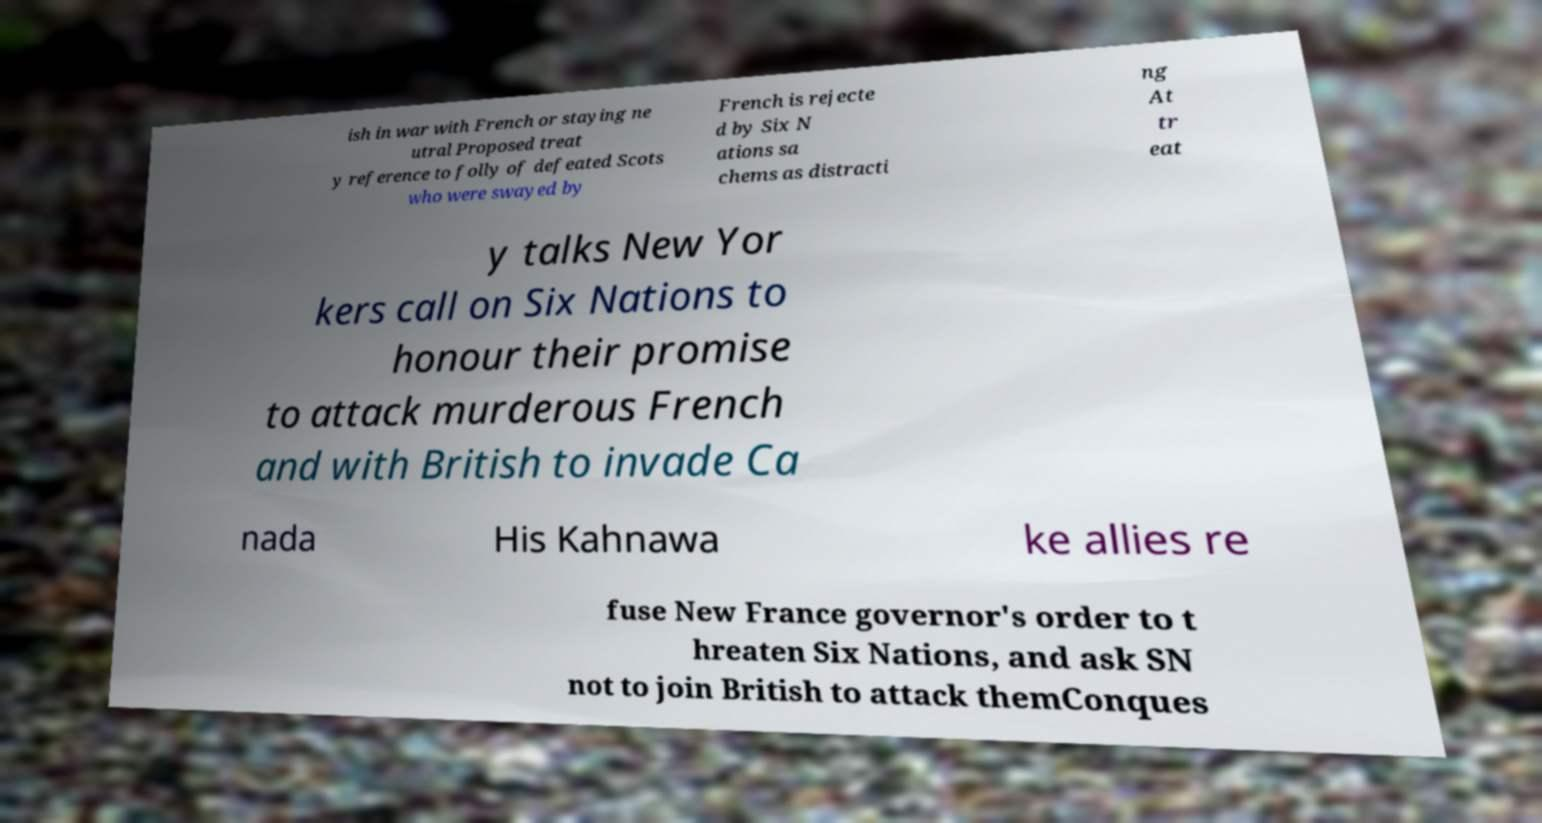For documentation purposes, I need the text within this image transcribed. Could you provide that? ish in war with French or staying ne utral Proposed treat y reference to folly of defeated Scots who were swayed by French is rejecte d by Six N ations sa chems as distracti ng At tr eat y talks New Yor kers call on Six Nations to honour their promise to attack murderous French and with British to invade Ca nada His Kahnawa ke allies re fuse New France governor's order to t hreaten Six Nations, and ask SN not to join British to attack themConques 